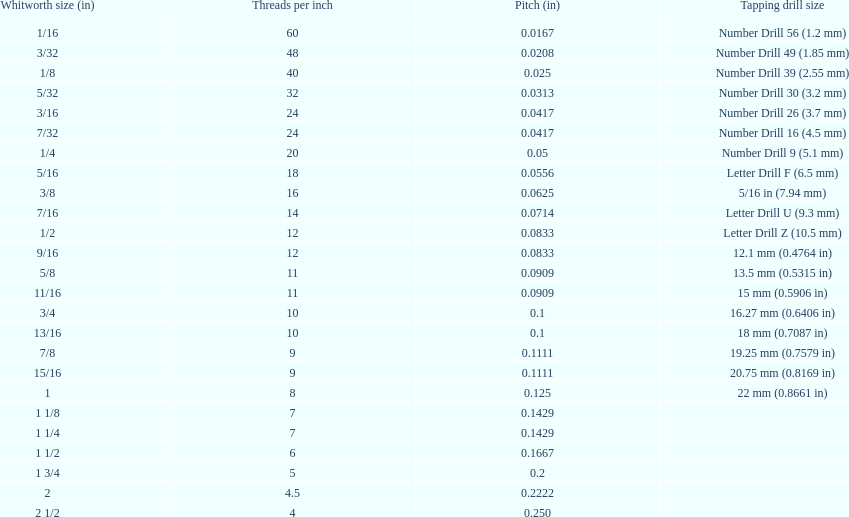Which whitworth size is the only one with 5 threads per inch? 1 3/4. 